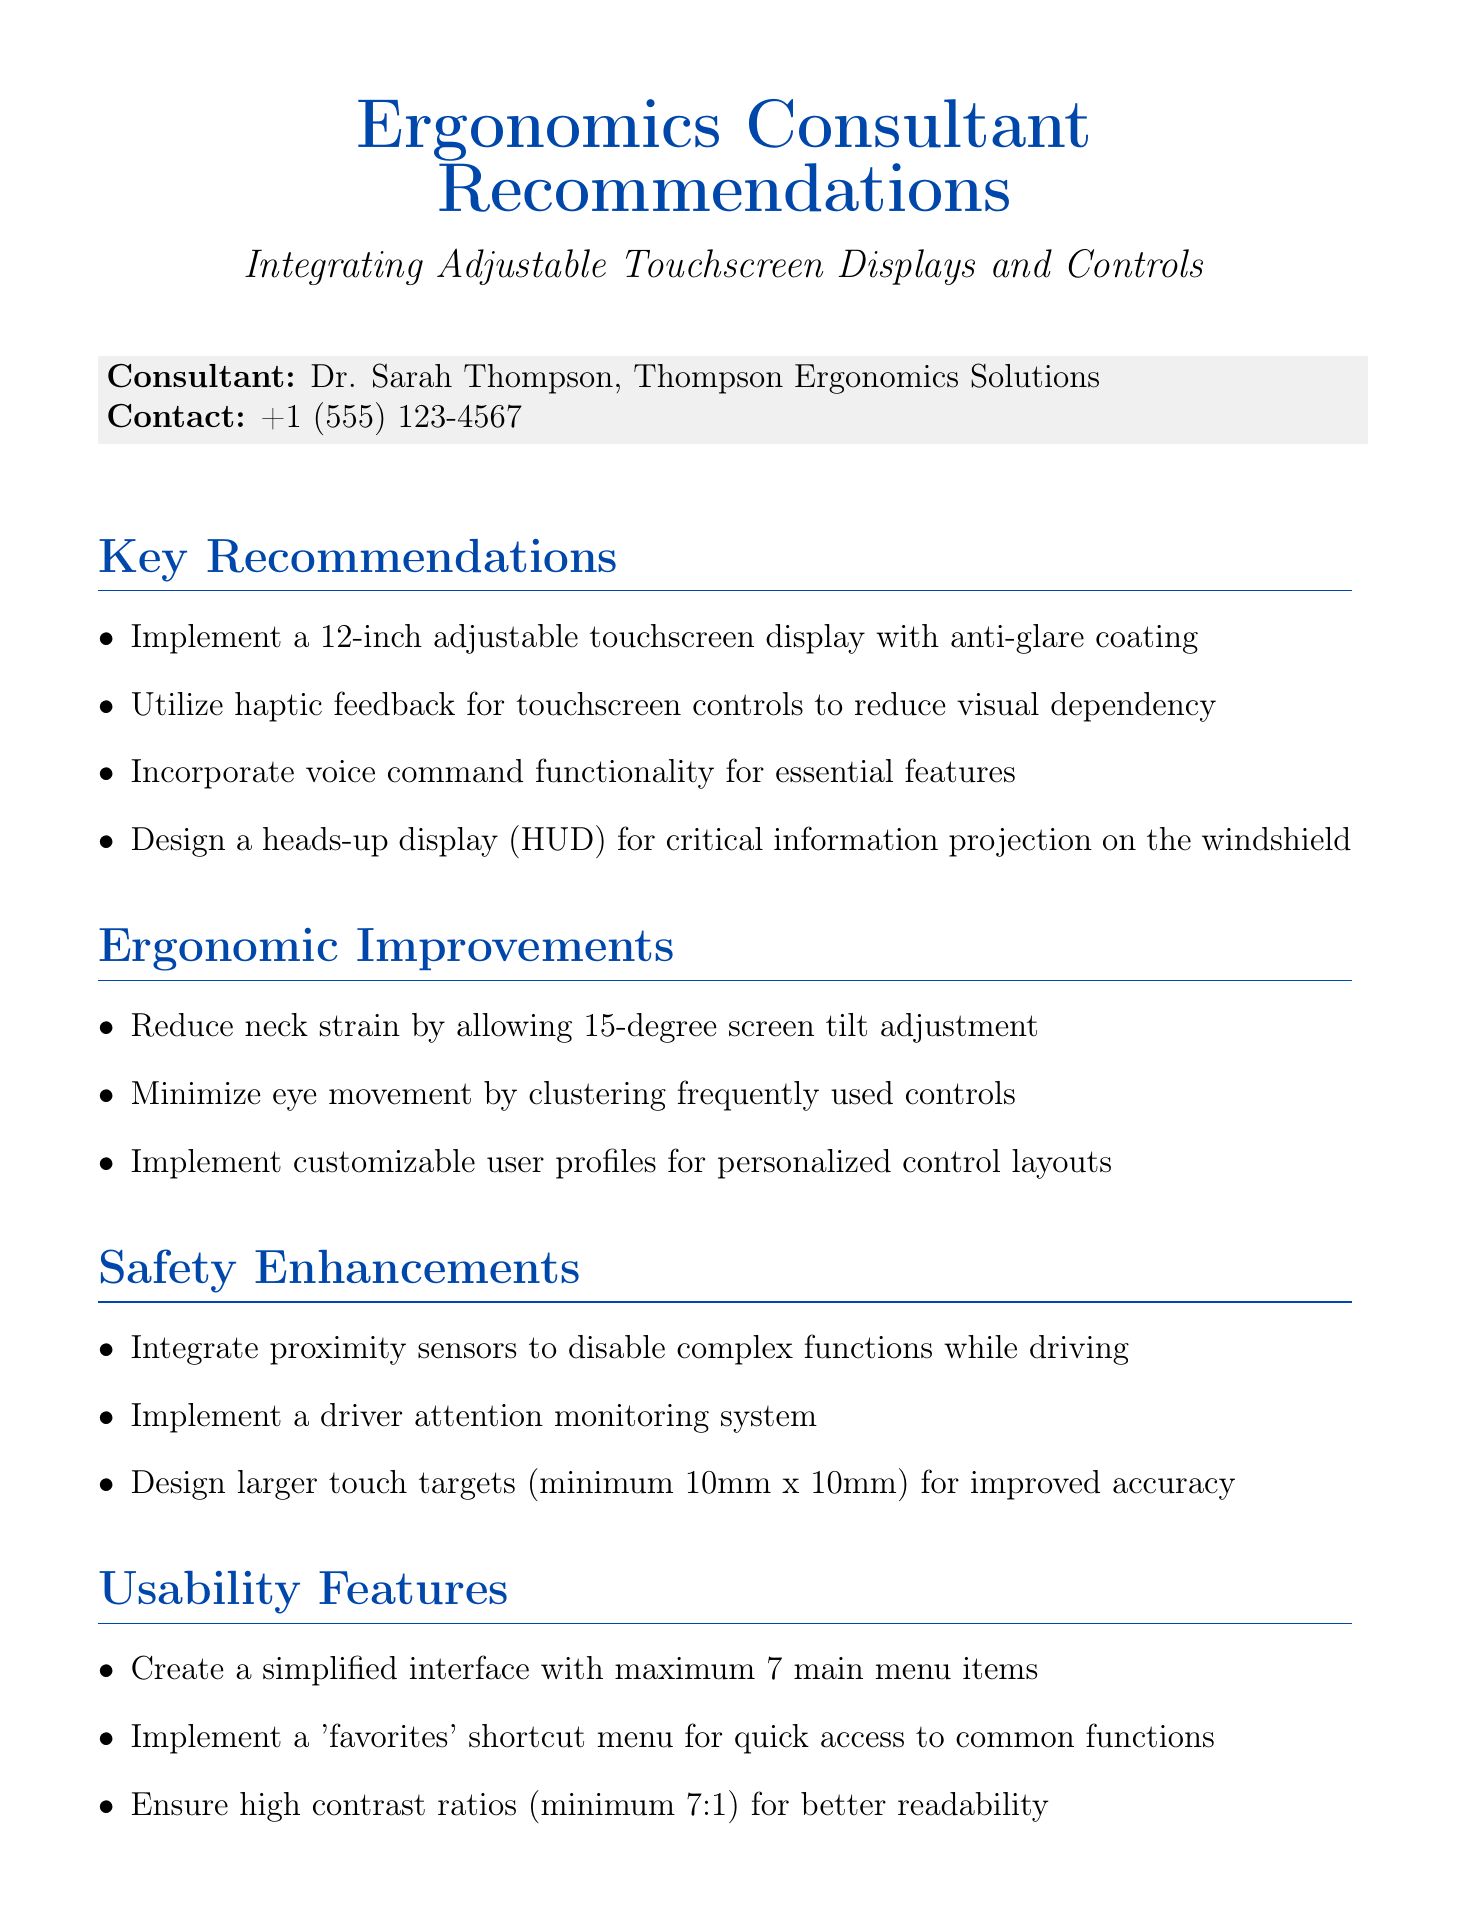What is the consultant's name? The consultant's name is mentioned in the introduction of the document as Dr. Sarah Thompson.
Answer: Dr. Sarah Thompson What is the recommended size for the adjustable touchscreen display? The size of the recommended adjustable touchscreen display is specified in the key recommendations section of the document.
Answer: 12-inch What is the minimum size for touch targets? The document specifies the minimum size for touch targets in the safety enhancements section.
Answer: 10mm x 10mm How long is the prototype development phase? This duration is mentioned in the implementation timeline table of the document.
Answer: 2 months What ergonomic improvement is suggested to reduce neck strain? The document highlights that a specific screen tilt adjustment helps reduce neck strain in the ergonomic improvements section.
Answer: 15-degree screen tilt adjustment What is the maximum number of main menu items suggested for the interface? The maximum number of main menu items is provided in the usability features section.
Answer: 7 What is one feature recommended for improving driver safety? The safety enhancements section includes features aimed at improving driver safety.
Answer: Driver attention monitoring system How long will the entire implementation take? The total time for the phases listed in the timeline can be added to find the entire implementation duration.
Answer: 12 months 